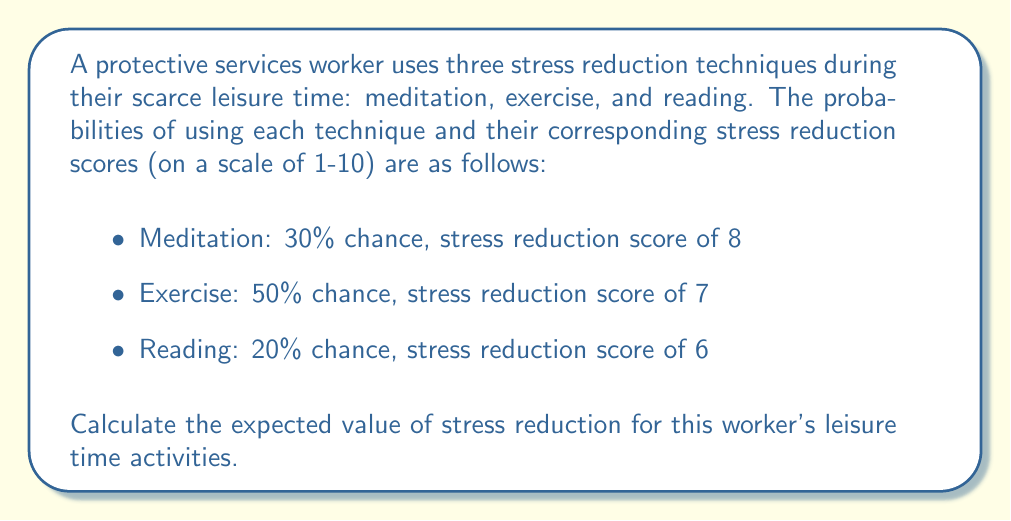Provide a solution to this math problem. To calculate the expected value of stress reduction, we need to follow these steps:

1. Identify the probability and stress reduction score for each technique:
   - Meditation: $p_1 = 0.30$, $s_1 = 8$
   - Exercise: $p_2 = 0.50$, $s_2 = 7$
   - Reading: $p_3 = 0.20$, $s_3 = 6$

2. Calculate the expected value using the formula:
   $$E = \sum_{i=1}^{n} p_i \cdot s_i$$
   Where $E$ is the expected value, $p_i$ is the probability of each outcome, and $s_i$ is the stress reduction score for each outcome.

3. Substitute the values into the formula:
   $$E = (0.30 \cdot 8) + (0.50 \cdot 7) + (0.20 \cdot 6)$$

4. Perform the calculations:
   $$E = 2.40 + 3.50 + 1.20$$

5. Sum up the results:
   $$E = 7.10$$

Therefore, the expected value of stress reduction for the worker's leisure time activities is 7.10 on a scale of 1-10.
Answer: 7.10 